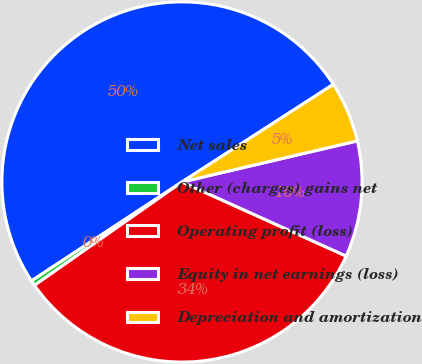<chart> <loc_0><loc_0><loc_500><loc_500><pie_chart><fcel>Net sales<fcel>Other (charges) gains net<fcel>Operating profit (loss)<fcel>Equity in net earnings (loss)<fcel>Depreciation and amortization<nl><fcel>50.14%<fcel>0.48%<fcel>33.52%<fcel>10.41%<fcel>5.45%<nl></chart> 